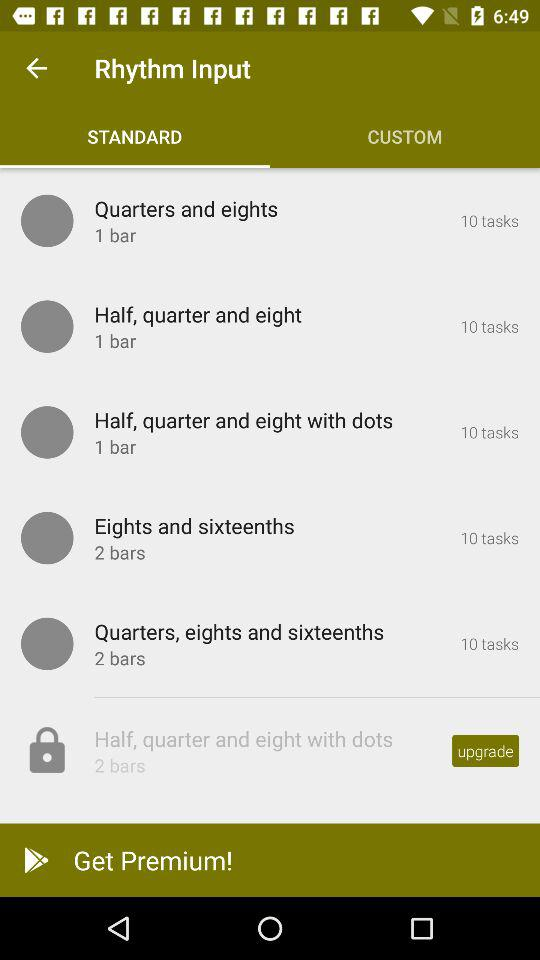Which option has been selected in the "Rhythm Input"? The selected option is "STANDARD". 